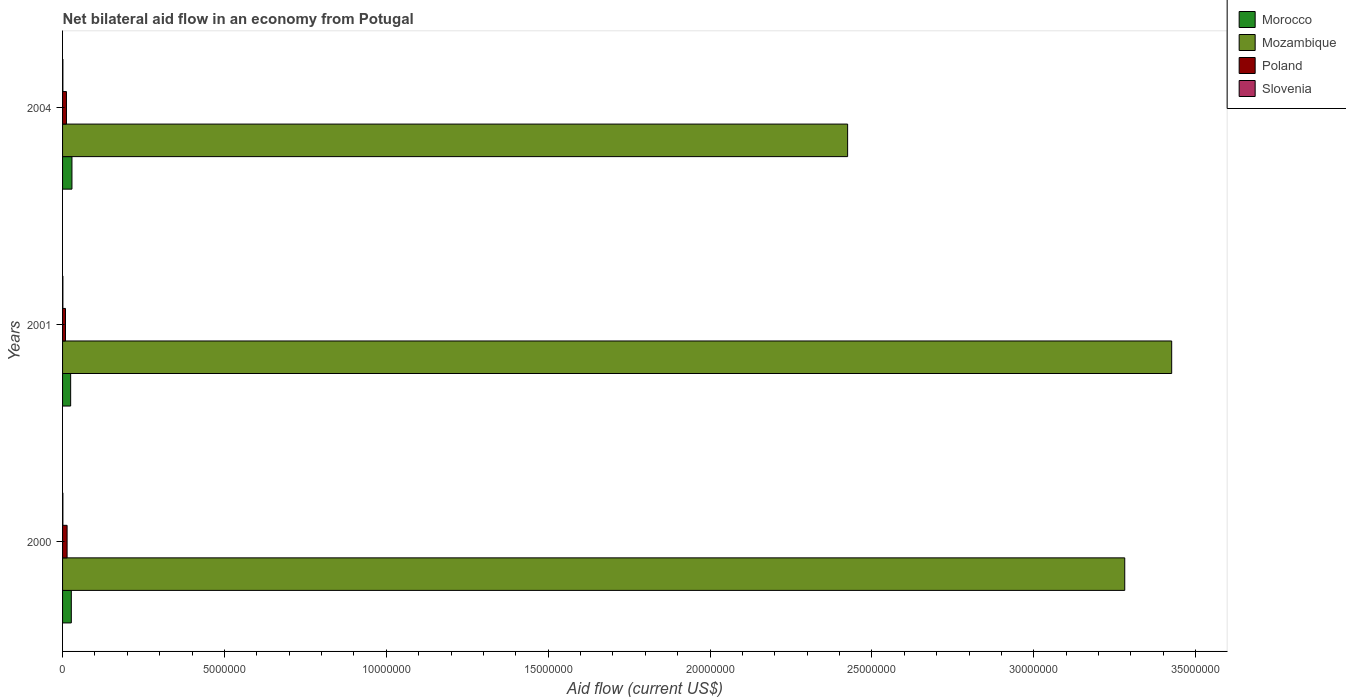How many different coloured bars are there?
Ensure brevity in your answer.  4. How many groups of bars are there?
Provide a short and direct response. 3. Are the number of bars per tick equal to the number of legend labels?
Make the answer very short. Yes. How many bars are there on the 3rd tick from the top?
Ensure brevity in your answer.  4. How many bars are there on the 2nd tick from the bottom?
Make the answer very short. 4. What is the label of the 3rd group of bars from the top?
Give a very brief answer. 2000. What is the net bilateral aid flow in Mozambique in 2001?
Ensure brevity in your answer.  3.43e+07. In which year was the net bilateral aid flow in Morocco maximum?
Offer a very short reply. 2004. In which year was the net bilateral aid flow in Poland minimum?
Offer a very short reply. 2001. What is the total net bilateral aid flow in Poland in the graph?
Make the answer very short. 3.50e+05. What is the difference between the net bilateral aid flow in Morocco in 2004 and the net bilateral aid flow in Mozambique in 2001?
Your response must be concise. -3.40e+07. What is the average net bilateral aid flow in Poland per year?
Give a very brief answer. 1.17e+05. In the year 2000, what is the difference between the net bilateral aid flow in Poland and net bilateral aid flow in Slovenia?
Offer a very short reply. 1.30e+05. What is the ratio of the net bilateral aid flow in Mozambique in 2000 to that in 2001?
Your answer should be compact. 0.96. Is the net bilateral aid flow in Slovenia in 2000 less than that in 2001?
Offer a very short reply. No. Is the difference between the net bilateral aid flow in Poland in 2000 and 2001 greater than the difference between the net bilateral aid flow in Slovenia in 2000 and 2001?
Your answer should be very brief. Yes. What is the difference between the highest and the lowest net bilateral aid flow in Morocco?
Your answer should be compact. 4.00e+04. In how many years, is the net bilateral aid flow in Poland greater than the average net bilateral aid flow in Poland taken over all years?
Offer a terse response. 2. Is it the case that in every year, the sum of the net bilateral aid flow in Morocco and net bilateral aid flow in Slovenia is greater than the sum of net bilateral aid flow in Mozambique and net bilateral aid flow in Poland?
Offer a very short reply. Yes. What does the 3rd bar from the top in 2001 represents?
Ensure brevity in your answer.  Mozambique. Is it the case that in every year, the sum of the net bilateral aid flow in Slovenia and net bilateral aid flow in Mozambique is greater than the net bilateral aid flow in Morocco?
Keep it short and to the point. Yes. How many bars are there?
Give a very brief answer. 12. How many years are there in the graph?
Make the answer very short. 3. What is the difference between two consecutive major ticks on the X-axis?
Give a very brief answer. 5.00e+06. Does the graph contain any zero values?
Give a very brief answer. No. How many legend labels are there?
Your response must be concise. 4. What is the title of the graph?
Your answer should be compact. Net bilateral aid flow in an economy from Potugal. Does "Cameroon" appear as one of the legend labels in the graph?
Provide a short and direct response. No. What is the label or title of the X-axis?
Provide a succinct answer. Aid flow (current US$). What is the label or title of the Y-axis?
Provide a succinct answer. Years. What is the Aid flow (current US$) of Morocco in 2000?
Offer a terse response. 2.70e+05. What is the Aid flow (current US$) in Mozambique in 2000?
Provide a succinct answer. 3.28e+07. What is the Aid flow (current US$) in Mozambique in 2001?
Your answer should be compact. 3.43e+07. What is the Aid flow (current US$) in Poland in 2001?
Provide a short and direct response. 9.00e+04. What is the Aid flow (current US$) in Mozambique in 2004?
Give a very brief answer. 2.42e+07. What is the Aid flow (current US$) of Poland in 2004?
Offer a terse response. 1.20e+05. What is the Aid flow (current US$) in Slovenia in 2004?
Your response must be concise. 10000. Across all years, what is the maximum Aid flow (current US$) of Morocco?
Your answer should be very brief. 2.90e+05. Across all years, what is the maximum Aid flow (current US$) in Mozambique?
Give a very brief answer. 3.43e+07. Across all years, what is the maximum Aid flow (current US$) of Poland?
Provide a short and direct response. 1.40e+05. Across all years, what is the maximum Aid flow (current US$) of Slovenia?
Offer a very short reply. 10000. Across all years, what is the minimum Aid flow (current US$) of Mozambique?
Provide a short and direct response. 2.42e+07. Across all years, what is the minimum Aid flow (current US$) of Slovenia?
Your answer should be compact. 10000. What is the total Aid flow (current US$) of Morocco in the graph?
Provide a short and direct response. 8.10e+05. What is the total Aid flow (current US$) in Mozambique in the graph?
Give a very brief answer. 9.13e+07. What is the total Aid flow (current US$) in Slovenia in the graph?
Your answer should be compact. 3.00e+04. What is the difference between the Aid flow (current US$) of Mozambique in 2000 and that in 2001?
Make the answer very short. -1.45e+06. What is the difference between the Aid flow (current US$) in Poland in 2000 and that in 2001?
Keep it short and to the point. 5.00e+04. What is the difference between the Aid flow (current US$) in Mozambique in 2000 and that in 2004?
Keep it short and to the point. 8.56e+06. What is the difference between the Aid flow (current US$) of Mozambique in 2001 and that in 2004?
Ensure brevity in your answer.  1.00e+07. What is the difference between the Aid flow (current US$) in Poland in 2001 and that in 2004?
Keep it short and to the point. -3.00e+04. What is the difference between the Aid flow (current US$) in Slovenia in 2001 and that in 2004?
Provide a succinct answer. 0. What is the difference between the Aid flow (current US$) of Morocco in 2000 and the Aid flow (current US$) of Mozambique in 2001?
Your answer should be compact. -3.40e+07. What is the difference between the Aid flow (current US$) of Morocco in 2000 and the Aid flow (current US$) of Poland in 2001?
Provide a succinct answer. 1.80e+05. What is the difference between the Aid flow (current US$) in Morocco in 2000 and the Aid flow (current US$) in Slovenia in 2001?
Keep it short and to the point. 2.60e+05. What is the difference between the Aid flow (current US$) in Mozambique in 2000 and the Aid flow (current US$) in Poland in 2001?
Your answer should be very brief. 3.27e+07. What is the difference between the Aid flow (current US$) of Mozambique in 2000 and the Aid flow (current US$) of Slovenia in 2001?
Provide a short and direct response. 3.28e+07. What is the difference between the Aid flow (current US$) of Morocco in 2000 and the Aid flow (current US$) of Mozambique in 2004?
Your answer should be compact. -2.40e+07. What is the difference between the Aid flow (current US$) of Morocco in 2000 and the Aid flow (current US$) of Poland in 2004?
Provide a short and direct response. 1.50e+05. What is the difference between the Aid flow (current US$) in Morocco in 2000 and the Aid flow (current US$) in Slovenia in 2004?
Your answer should be very brief. 2.60e+05. What is the difference between the Aid flow (current US$) in Mozambique in 2000 and the Aid flow (current US$) in Poland in 2004?
Give a very brief answer. 3.27e+07. What is the difference between the Aid flow (current US$) in Mozambique in 2000 and the Aid flow (current US$) in Slovenia in 2004?
Provide a short and direct response. 3.28e+07. What is the difference between the Aid flow (current US$) in Morocco in 2001 and the Aid flow (current US$) in Mozambique in 2004?
Your response must be concise. -2.40e+07. What is the difference between the Aid flow (current US$) in Morocco in 2001 and the Aid flow (current US$) in Poland in 2004?
Offer a very short reply. 1.30e+05. What is the difference between the Aid flow (current US$) of Mozambique in 2001 and the Aid flow (current US$) of Poland in 2004?
Offer a terse response. 3.41e+07. What is the difference between the Aid flow (current US$) of Mozambique in 2001 and the Aid flow (current US$) of Slovenia in 2004?
Keep it short and to the point. 3.42e+07. What is the difference between the Aid flow (current US$) of Poland in 2001 and the Aid flow (current US$) of Slovenia in 2004?
Provide a succinct answer. 8.00e+04. What is the average Aid flow (current US$) of Mozambique per year?
Provide a succinct answer. 3.04e+07. What is the average Aid flow (current US$) in Poland per year?
Make the answer very short. 1.17e+05. What is the average Aid flow (current US$) in Slovenia per year?
Provide a succinct answer. 10000. In the year 2000, what is the difference between the Aid flow (current US$) of Morocco and Aid flow (current US$) of Mozambique?
Make the answer very short. -3.25e+07. In the year 2000, what is the difference between the Aid flow (current US$) in Morocco and Aid flow (current US$) in Poland?
Ensure brevity in your answer.  1.30e+05. In the year 2000, what is the difference between the Aid flow (current US$) in Morocco and Aid flow (current US$) in Slovenia?
Offer a very short reply. 2.60e+05. In the year 2000, what is the difference between the Aid flow (current US$) in Mozambique and Aid flow (current US$) in Poland?
Keep it short and to the point. 3.27e+07. In the year 2000, what is the difference between the Aid flow (current US$) in Mozambique and Aid flow (current US$) in Slovenia?
Provide a short and direct response. 3.28e+07. In the year 2000, what is the difference between the Aid flow (current US$) in Poland and Aid flow (current US$) in Slovenia?
Your answer should be very brief. 1.30e+05. In the year 2001, what is the difference between the Aid flow (current US$) in Morocco and Aid flow (current US$) in Mozambique?
Offer a very short reply. -3.40e+07. In the year 2001, what is the difference between the Aid flow (current US$) in Mozambique and Aid flow (current US$) in Poland?
Ensure brevity in your answer.  3.42e+07. In the year 2001, what is the difference between the Aid flow (current US$) in Mozambique and Aid flow (current US$) in Slovenia?
Your answer should be compact. 3.42e+07. In the year 2004, what is the difference between the Aid flow (current US$) in Morocco and Aid flow (current US$) in Mozambique?
Your answer should be very brief. -2.40e+07. In the year 2004, what is the difference between the Aid flow (current US$) of Morocco and Aid flow (current US$) of Slovenia?
Give a very brief answer. 2.80e+05. In the year 2004, what is the difference between the Aid flow (current US$) of Mozambique and Aid flow (current US$) of Poland?
Offer a terse response. 2.41e+07. In the year 2004, what is the difference between the Aid flow (current US$) in Mozambique and Aid flow (current US$) in Slovenia?
Ensure brevity in your answer.  2.42e+07. What is the ratio of the Aid flow (current US$) of Morocco in 2000 to that in 2001?
Give a very brief answer. 1.08. What is the ratio of the Aid flow (current US$) of Mozambique in 2000 to that in 2001?
Provide a succinct answer. 0.96. What is the ratio of the Aid flow (current US$) in Poland in 2000 to that in 2001?
Your answer should be compact. 1.56. What is the ratio of the Aid flow (current US$) in Slovenia in 2000 to that in 2001?
Keep it short and to the point. 1. What is the ratio of the Aid flow (current US$) in Mozambique in 2000 to that in 2004?
Your response must be concise. 1.35. What is the ratio of the Aid flow (current US$) of Poland in 2000 to that in 2004?
Make the answer very short. 1.17. What is the ratio of the Aid flow (current US$) of Slovenia in 2000 to that in 2004?
Your response must be concise. 1. What is the ratio of the Aid flow (current US$) in Morocco in 2001 to that in 2004?
Make the answer very short. 0.86. What is the ratio of the Aid flow (current US$) in Mozambique in 2001 to that in 2004?
Make the answer very short. 1.41. What is the ratio of the Aid flow (current US$) in Slovenia in 2001 to that in 2004?
Make the answer very short. 1. What is the difference between the highest and the second highest Aid flow (current US$) of Mozambique?
Offer a very short reply. 1.45e+06. What is the difference between the highest and the lowest Aid flow (current US$) of Morocco?
Your answer should be very brief. 4.00e+04. What is the difference between the highest and the lowest Aid flow (current US$) in Mozambique?
Provide a short and direct response. 1.00e+07. What is the difference between the highest and the lowest Aid flow (current US$) of Slovenia?
Your answer should be very brief. 0. 